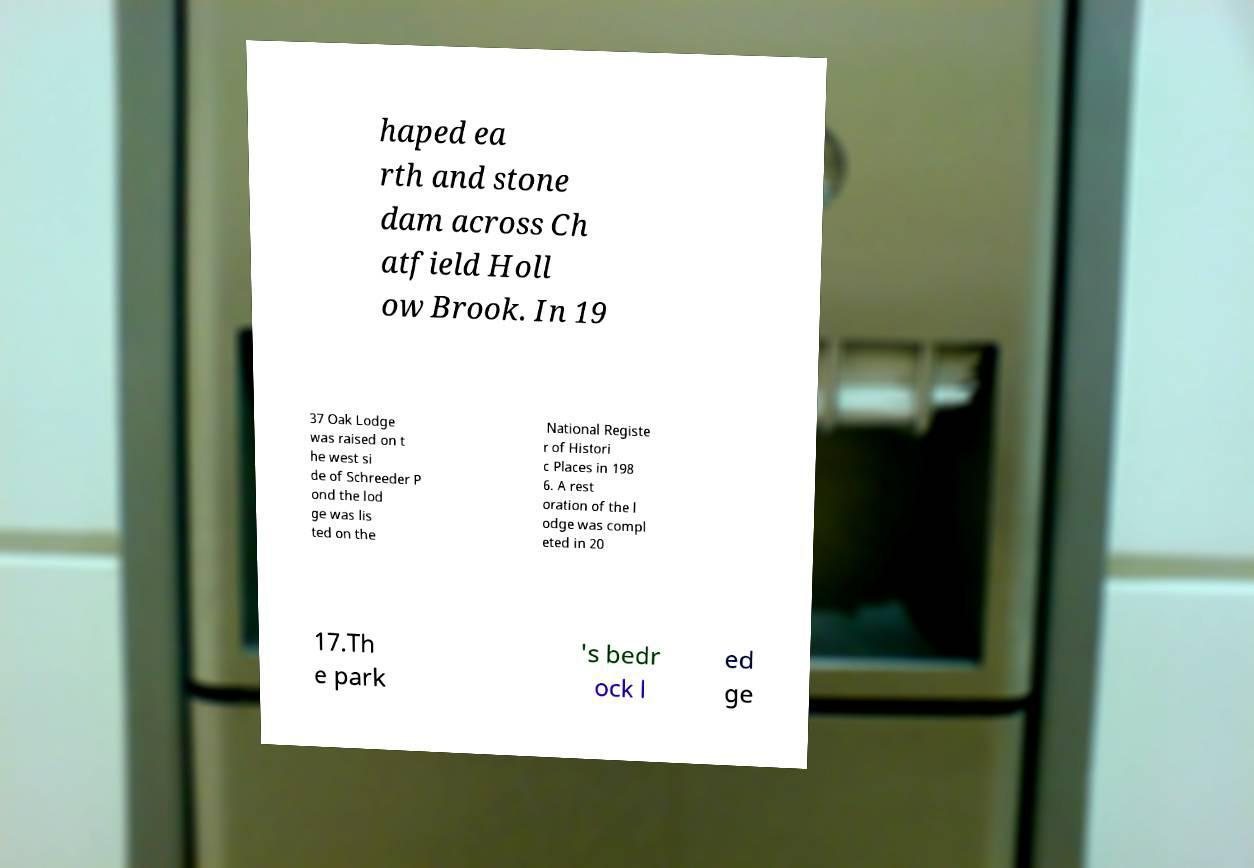What messages or text are displayed in this image? I need them in a readable, typed format. haped ea rth and stone dam across Ch atfield Holl ow Brook. In 19 37 Oak Lodge was raised on t he west si de of Schreeder P ond the lod ge was lis ted on the National Registe r of Histori c Places in 198 6. A rest oration of the l odge was compl eted in 20 17.Th e park 's bedr ock l ed ge 